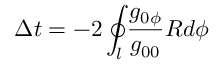<formula> <loc_0><loc_0><loc_500><loc_500>\Delta t = - 2 \oint _ { l } { \frac { g _ { 0 \phi } } { g _ { 0 0 } } R d \phi }</formula> 